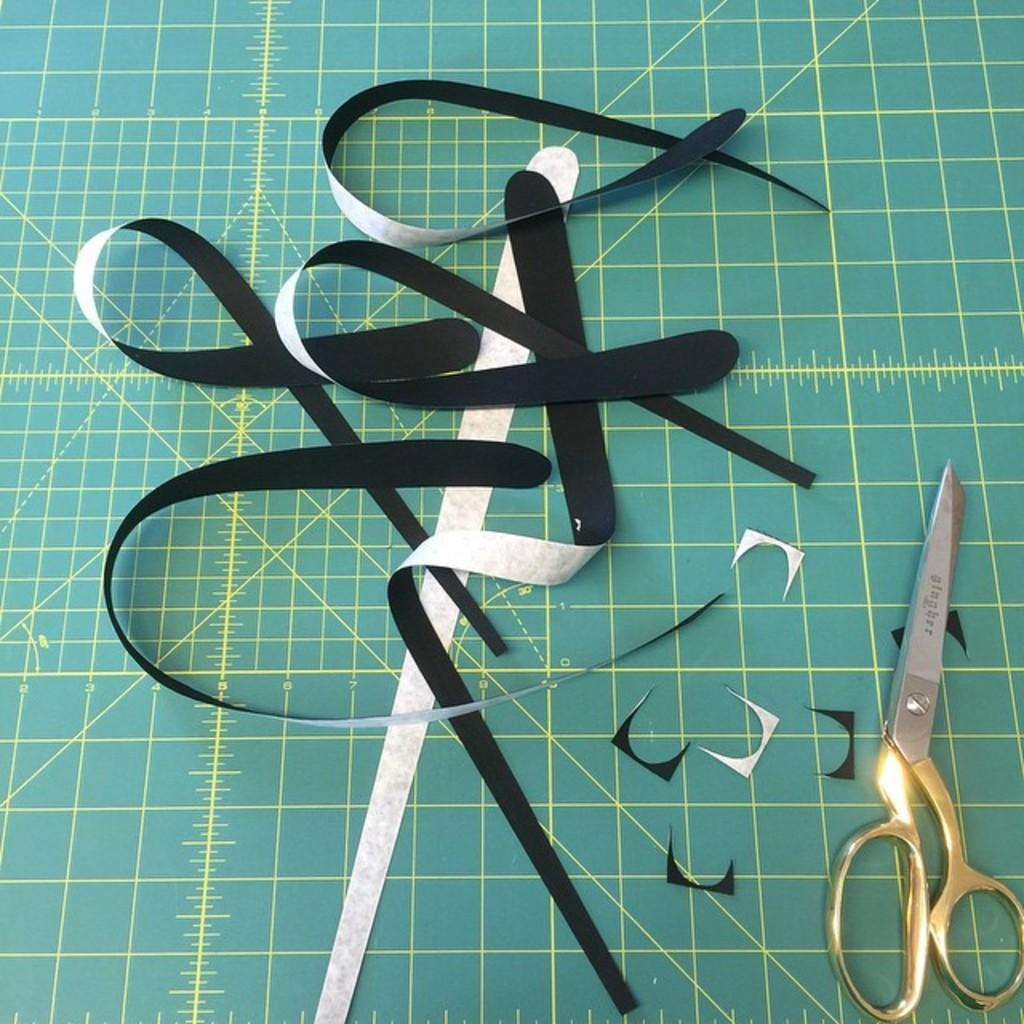What is the main object in the image? There is a measuring board in the image. What type of crafts can be seen in the image? There are paper crafts in the image. What tool is visible in the image? Scissors are visible in the image. What type of friction can be observed between the paper crafts and the measuring board in the image? There is no indication of friction between the paper crafts and the measuring board in the image. 